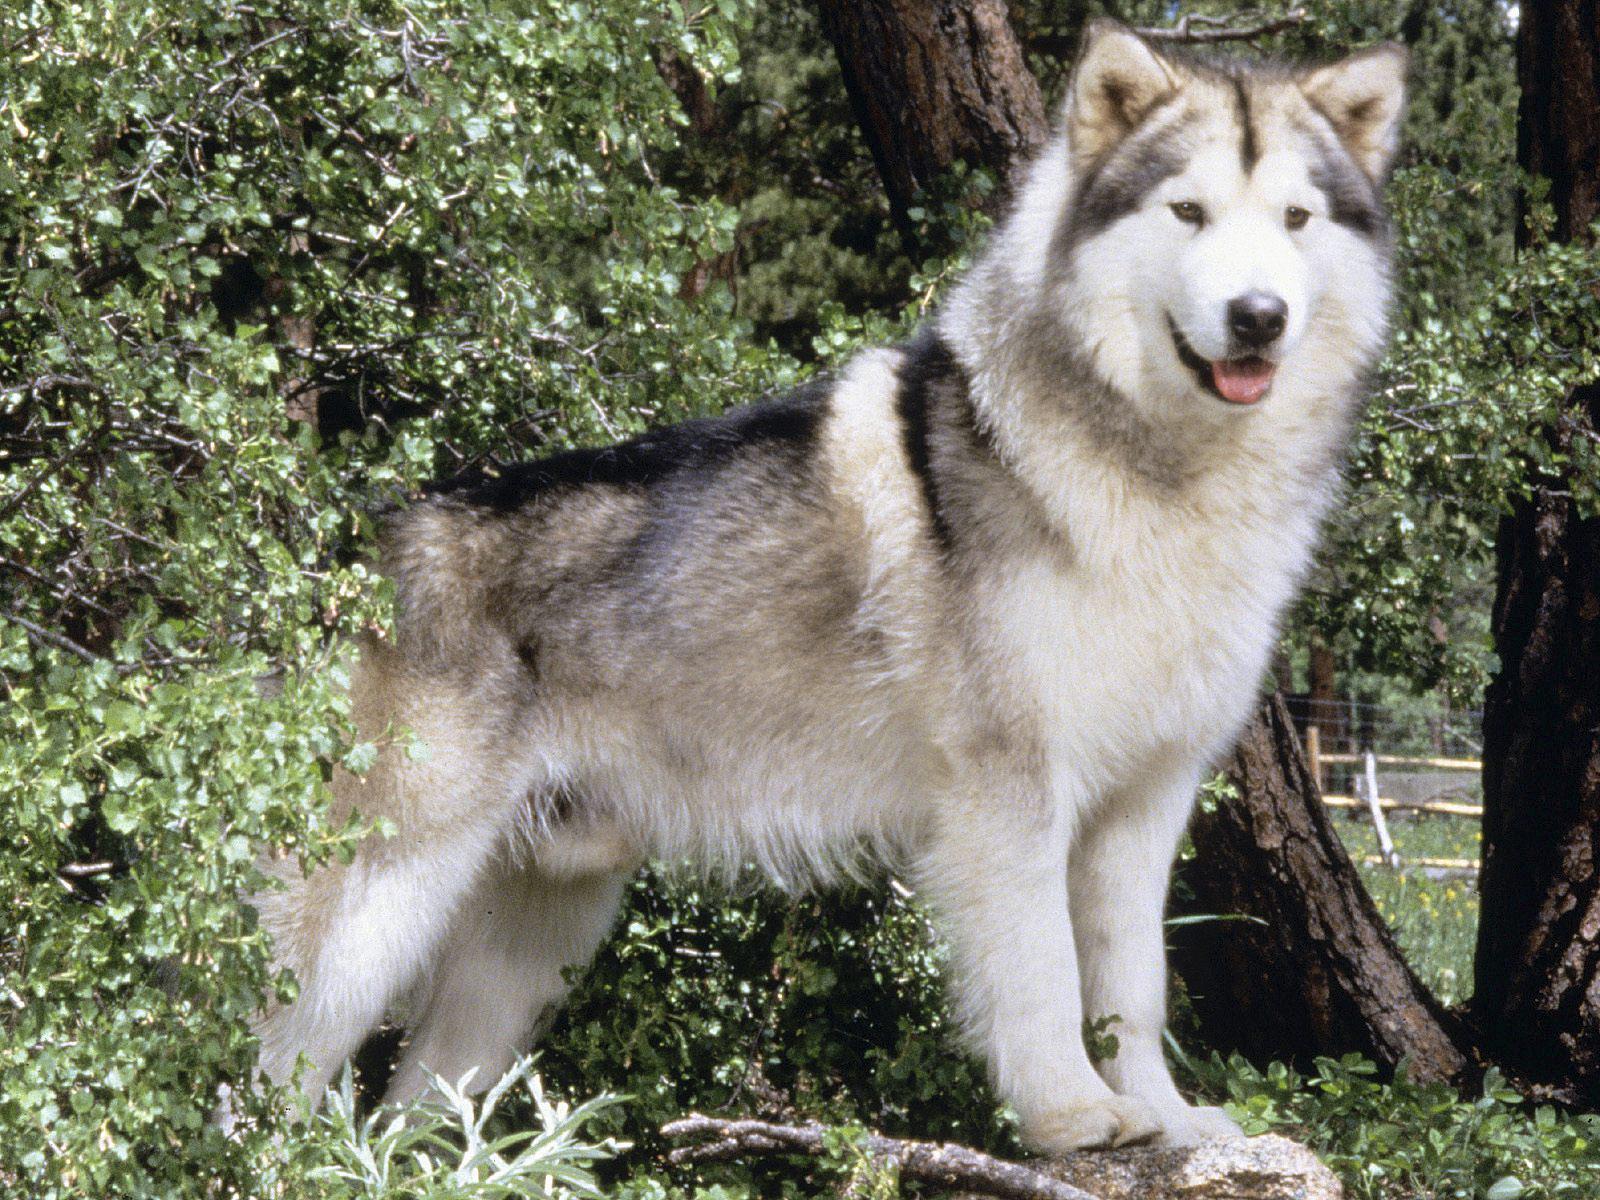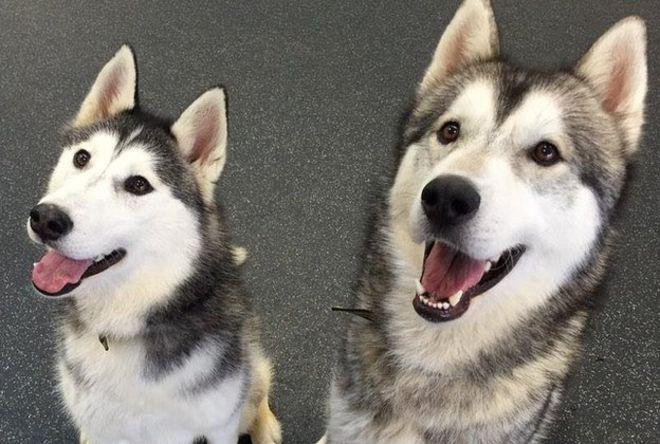The first image is the image on the left, the second image is the image on the right. Evaluate the accuracy of this statement regarding the images: "The left and right image contains the same number of dogs.". Is it true? Answer yes or no. No. 